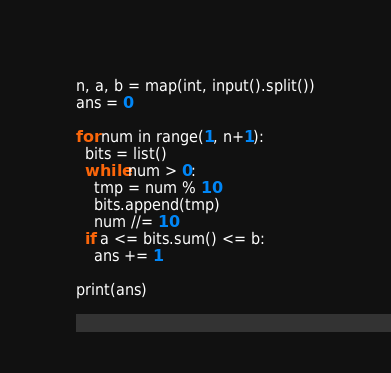Convert code to text. <code><loc_0><loc_0><loc_500><loc_500><_Python_>n, a, b = map(int, input().split())
ans = 0

for num in range(1, n+1):
  bits = list()
  while num > 0:
    tmp = num % 10
    bits.append(tmp)
    num //= 10
  if a <= bits.sum() <= b:
    ans += 1

print(ans)</code> 